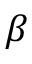Convert formula to latex. <formula><loc_0><loc_0><loc_500><loc_500>\beta</formula> 